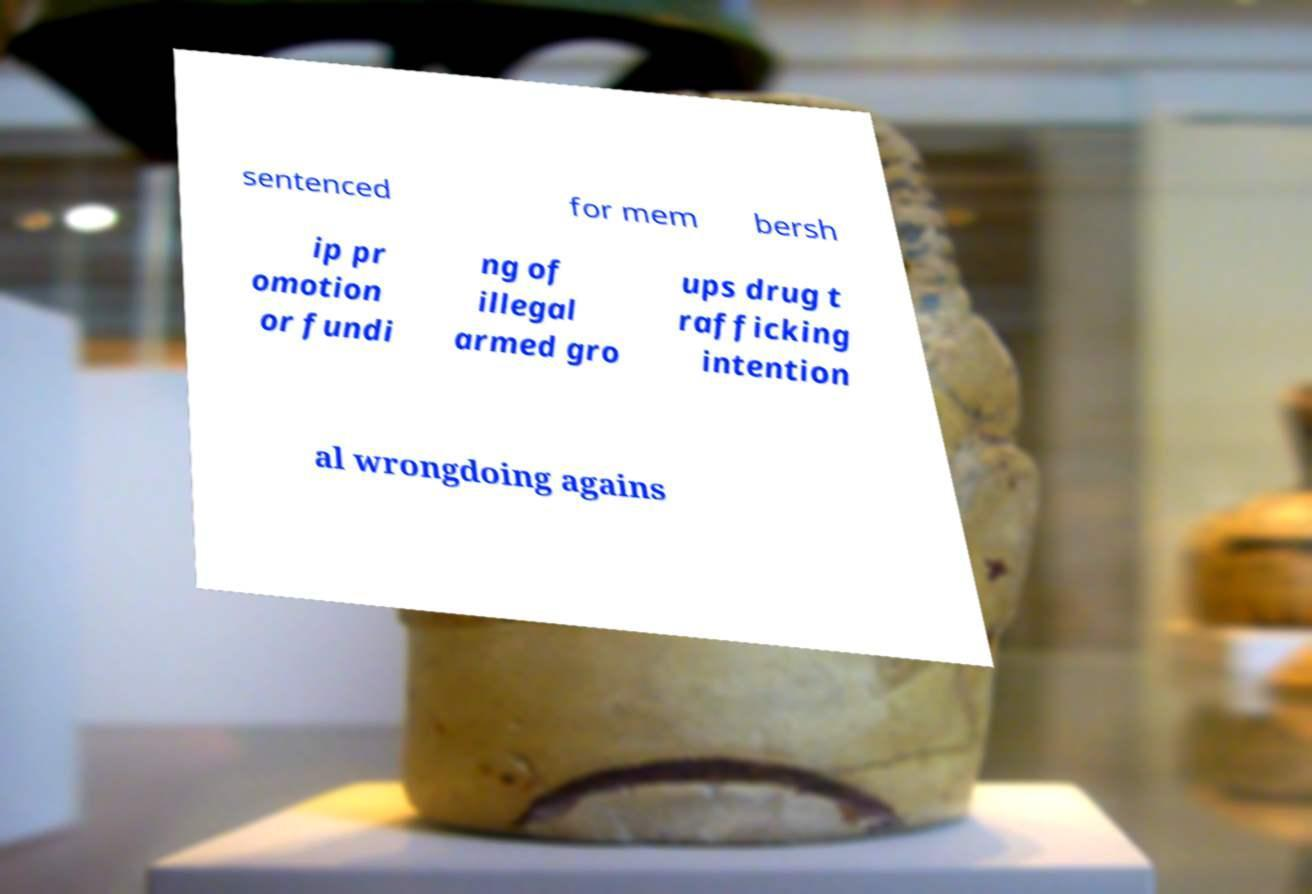There's text embedded in this image that I need extracted. Can you transcribe it verbatim? sentenced for mem bersh ip pr omotion or fundi ng of illegal armed gro ups drug t rafficking intention al wrongdoing agains 